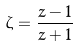<formula> <loc_0><loc_0><loc_500><loc_500>\zeta = \frac { z - 1 } { z + 1 }</formula> 